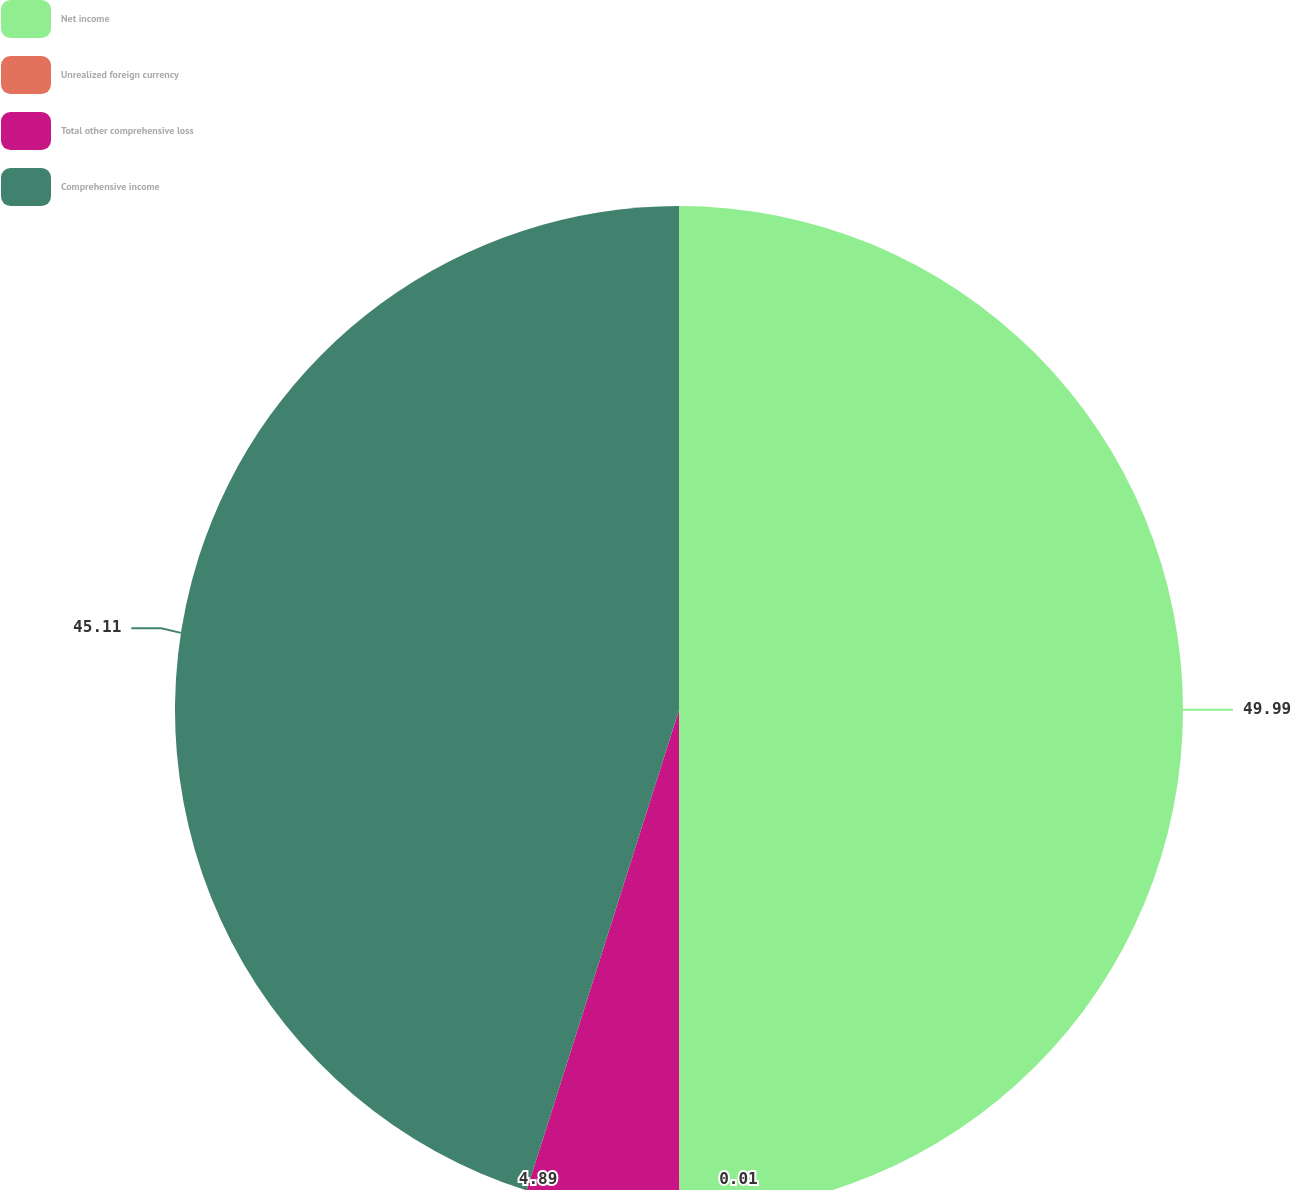<chart> <loc_0><loc_0><loc_500><loc_500><pie_chart><fcel>Net income<fcel>Unrealized foreign currency<fcel>Total other comprehensive loss<fcel>Comprehensive income<nl><fcel>49.99%<fcel>0.01%<fcel>4.89%<fcel>45.11%<nl></chart> 